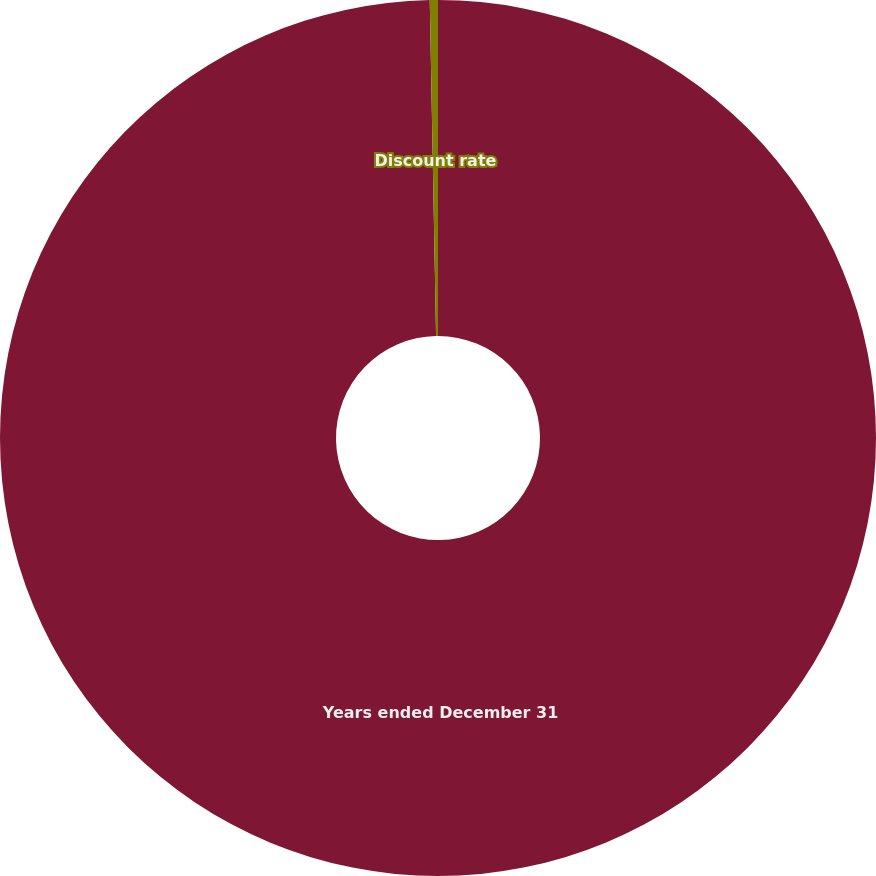<chart> <loc_0><loc_0><loc_500><loc_500><pie_chart><fcel>Years ended December 31<fcel>Discount rate<nl><fcel>99.7%<fcel>0.3%<nl></chart> 